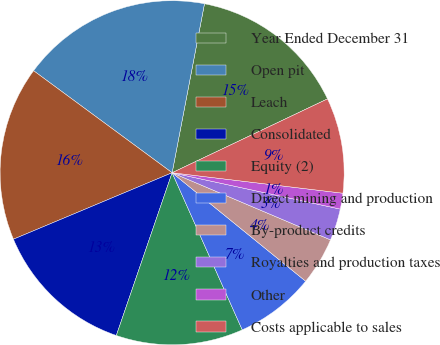Convert chart to OTSL. <chart><loc_0><loc_0><loc_500><loc_500><pie_chart><fcel>Year Ended December 31<fcel>Open pit<fcel>Leach<fcel>Consolidated<fcel>Equity (2)<fcel>Direct mining and production<fcel>By-product credits<fcel>Royalties and production taxes<fcel>Other<fcel>Costs applicable to sales<nl><fcel>14.93%<fcel>17.91%<fcel>16.42%<fcel>13.43%<fcel>11.94%<fcel>7.46%<fcel>4.48%<fcel>2.99%<fcel>1.49%<fcel>8.96%<nl></chart> 